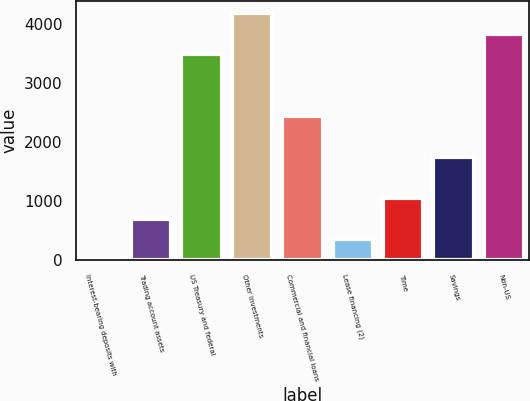Convert chart to OTSL. <chart><loc_0><loc_0><loc_500><loc_500><bar_chart><fcel>Interest-bearing deposits with<fcel>Trading account assets<fcel>US Treasury and federal<fcel>Other investments<fcel>Commercial and financial loans<fcel>Lease financing (2)<fcel>Time<fcel>Savings<fcel>Non-US<nl><fcel>1<fcel>697.2<fcel>3482<fcel>4178.2<fcel>2437.7<fcel>349.1<fcel>1045.3<fcel>1741.5<fcel>3830.1<nl></chart> 